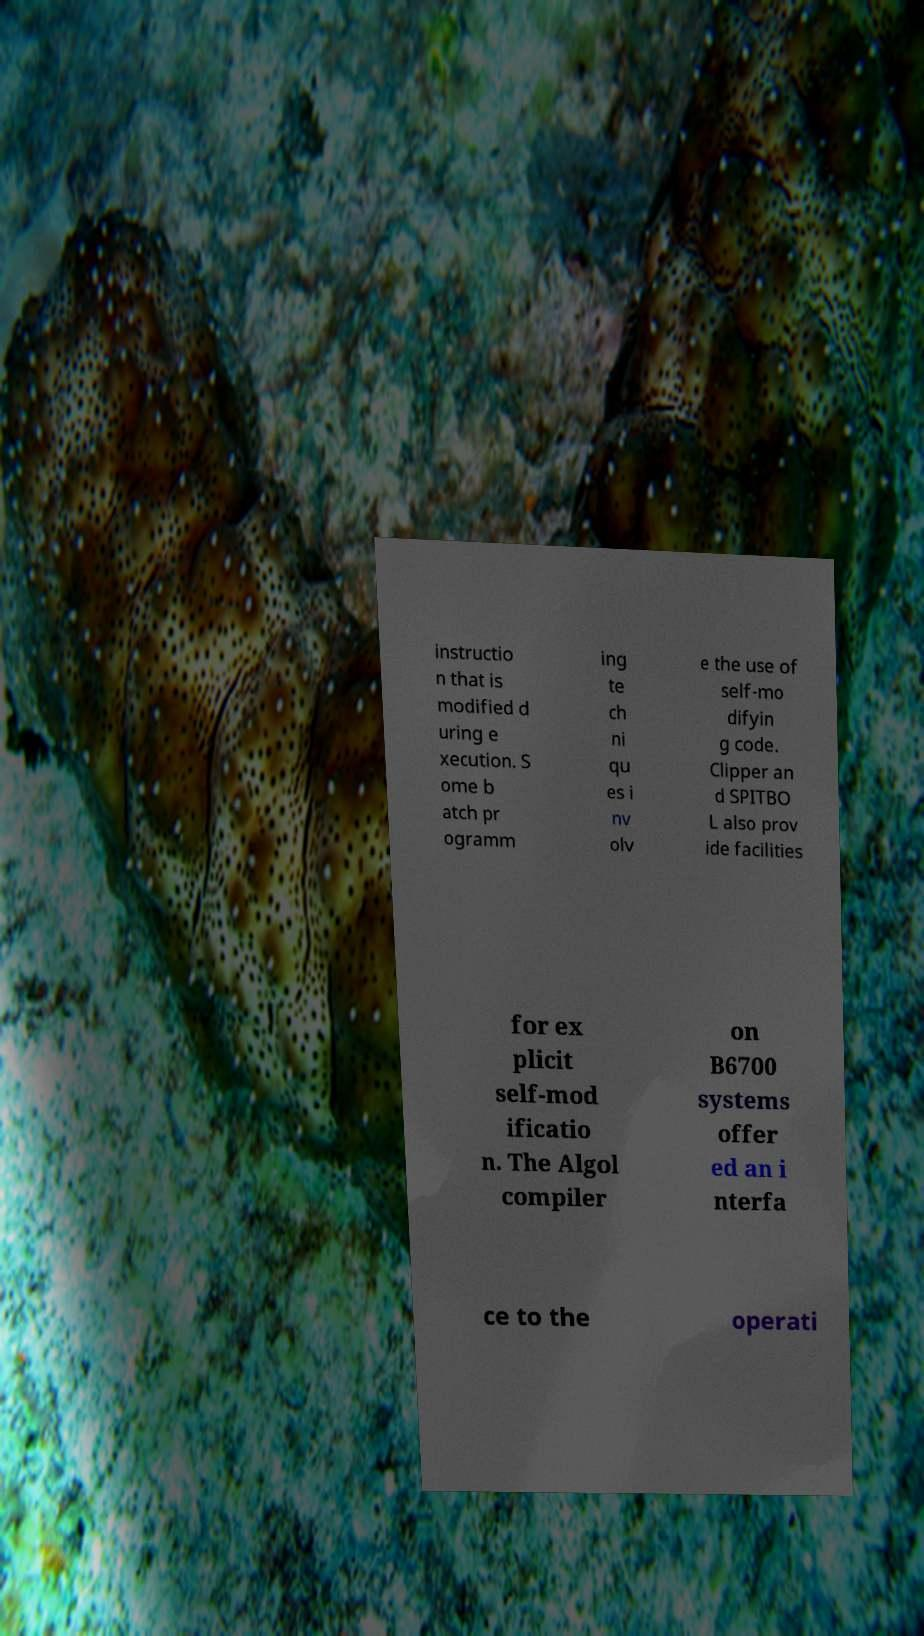I need the written content from this picture converted into text. Can you do that? instructio n that is modified d uring e xecution. S ome b atch pr ogramm ing te ch ni qu es i nv olv e the use of self-mo difyin g code. Clipper an d SPITBO L also prov ide facilities for ex plicit self-mod ificatio n. The Algol compiler on B6700 systems offer ed an i nterfa ce to the operati 